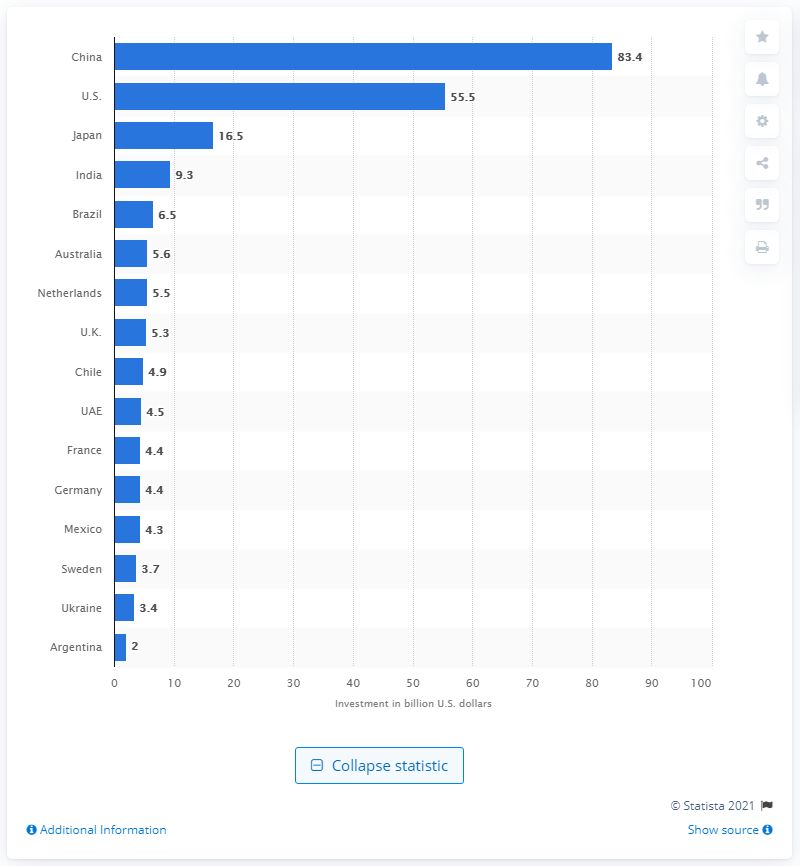Give some essential details in this illustration. In 2019, China invested a significant amount of money, approximately 83.4, in clean energy research and development. The United States and Japan invested a total of 83.4 billion dollars in clean energy in 2019. 